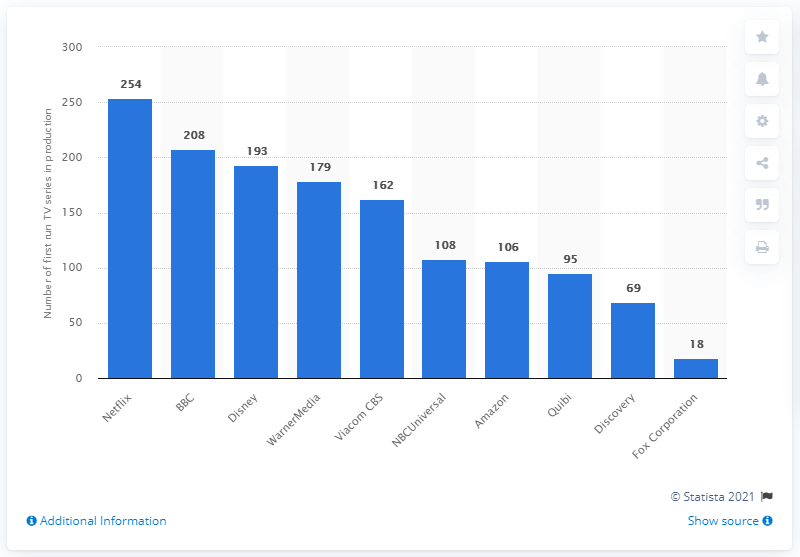Specify some key components in this picture. In January 2020, Netflix produced 254 TV series. As of January 2020, there were 193 television series in various stages of production. 